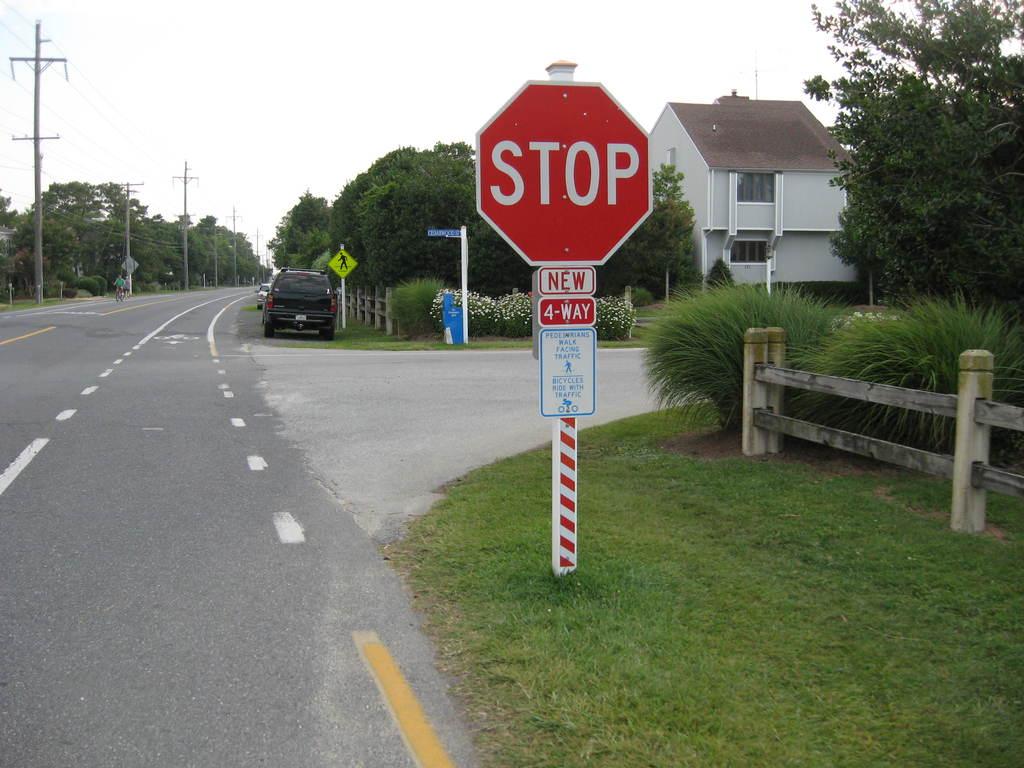Is the stop sign new or old?
Provide a succinct answer. New. 